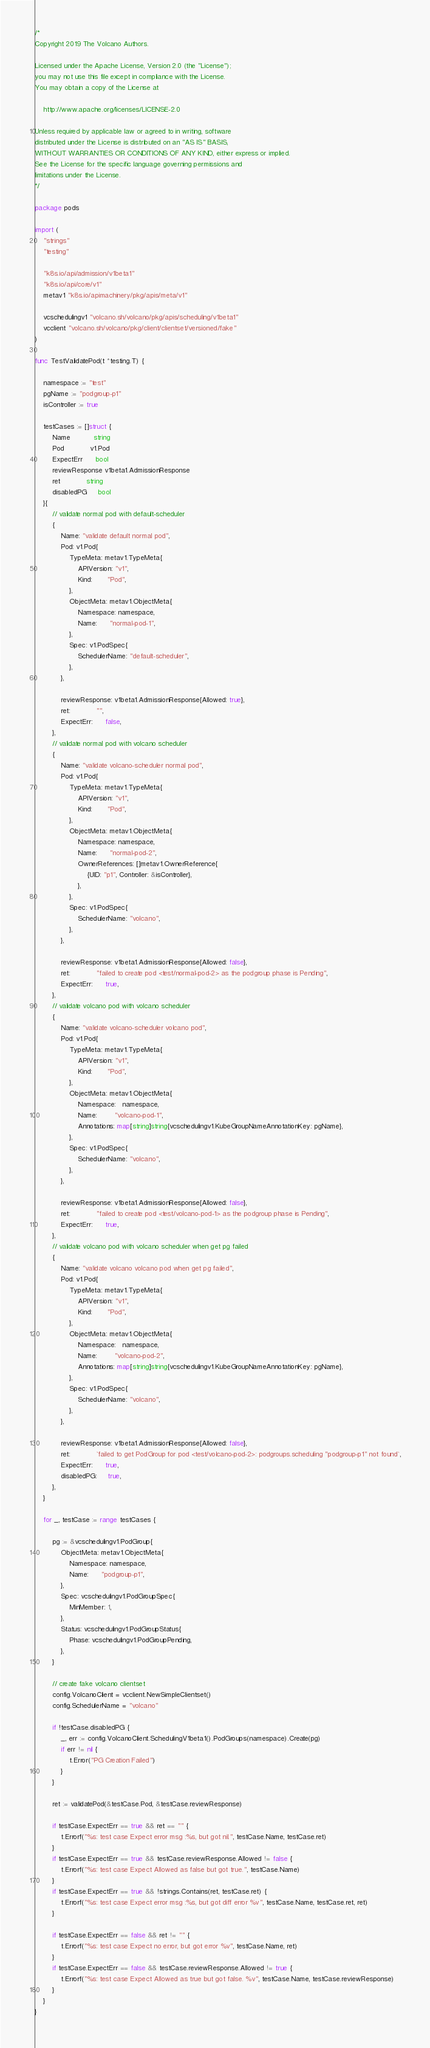Convert code to text. <code><loc_0><loc_0><loc_500><loc_500><_Go_>/*
Copyright 2019 The Volcano Authors.

Licensed under the Apache License, Version 2.0 (the "License");
you may not use this file except in compliance with the License.
You may obtain a copy of the License at

    http://www.apache.org/licenses/LICENSE-2.0

Unless required by applicable law or agreed to in writing, software
distributed under the License is distributed on an "AS IS" BASIS,
WITHOUT WARRANTIES OR CONDITIONS OF ANY KIND, either express or implied.
See the License for the specific language governing permissions and
limitations under the License.
*/

package pods

import (
	"strings"
	"testing"

	"k8s.io/api/admission/v1beta1"
	"k8s.io/api/core/v1"
	metav1 "k8s.io/apimachinery/pkg/apis/meta/v1"

	vcschedulingv1 "volcano.sh/volcano/pkg/apis/scheduling/v1beta1"
	vcclient "volcano.sh/volcano/pkg/client/clientset/versioned/fake"
)

func TestValidatePod(t *testing.T) {

	namespace := "test"
	pgName := "podgroup-p1"
	isController := true

	testCases := []struct {
		Name           string
		Pod            v1.Pod
		ExpectErr      bool
		reviewResponse v1beta1.AdmissionResponse
		ret            string
		disabledPG     bool
	}{
		// validate normal pod with default-scheduler
		{
			Name: "validate default normal pod",
			Pod: v1.Pod{
				TypeMeta: metav1.TypeMeta{
					APIVersion: "v1",
					Kind:       "Pod",
				},
				ObjectMeta: metav1.ObjectMeta{
					Namespace: namespace,
					Name:      "normal-pod-1",
				},
				Spec: v1.PodSpec{
					SchedulerName: "default-scheduler",
				},
			},

			reviewResponse: v1beta1.AdmissionResponse{Allowed: true},
			ret:            "",
			ExpectErr:      false,
		},
		// validate normal pod with volcano scheduler
		{
			Name: "validate volcano-scheduler normal pod",
			Pod: v1.Pod{
				TypeMeta: metav1.TypeMeta{
					APIVersion: "v1",
					Kind:       "Pod",
				},
				ObjectMeta: metav1.ObjectMeta{
					Namespace: namespace,
					Name:      "normal-pod-2",
					OwnerReferences: []metav1.OwnerReference{
						{UID: "p1", Controller: &isController},
					},
				},
				Spec: v1.PodSpec{
					SchedulerName: "volcano",
				},
			},

			reviewResponse: v1beta1.AdmissionResponse{Allowed: false},
			ret:            "failed to create pod <test/normal-pod-2> as the podgroup phase is Pending",
			ExpectErr:      true,
		},
		// validate volcano pod with volcano scheduler
		{
			Name: "validate volcano-scheduler volcano pod",
			Pod: v1.Pod{
				TypeMeta: metav1.TypeMeta{
					APIVersion: "v1",
					Kind:       "Pod",
				},
				ObjectMeta: metav1.ObjectMeta{
					Namespace:   namespace,
					Name:        "volcano-pod-1",
					Annotations: map[string]string{vcschedulingv1.KubeGroupNameAnnotationKey: pgName},
				},
				Spec: v1.PodSpec{
					SchedulerName: "volcano",
				},
			},

			reviewResponse: v1beta1.AdmissionResponse{Allowed: false},
			ret:            "failed to create pod <test/volcano-pod-1> as the podgroup phase is Pending",
			ExpectErr:      true,
		},
		// validate volcano pod with volcano scheduler when get pg failed
		{
			Name: "validate volcano volcano pod when get pg failed",
			Pod: v1.Pod{
				TypeMeta: metav1.TypeMeta{
					APIVersion: "v1",
					Kind:       "Pod",
				},
				ObjectMeta: metav1.ObjectMeta{
					Namespace:   namespace,
					Name:        "volcano-pod-2",
					Annotations: map[string]string{vcschedulingv1.KubeGroupNameAnnotationKey: pgName},
				},
				Spec: v1.PodSpec{
					SchedulerName: "volcano",
				},
			},

			reviewResponse: v1beta1.AdmissionResponse{Allowed: false},
			ret:            `failed to get PodGroup for pod <test/volcano-pod-2>: podgroups.scheduling "podgroup-p1" not found`,
			ExpectErr:      true,
			disabledPG:     true,
		},
	}

	for _, testCase := range testCases {

		pg := &vcschedulingv1.PodGroup{
			ObjectMeta: metav1.ObjectMeta{
				Namespace: namespace,
				Name:      "podgroup-p1",
			},
			Spec: vcschedulingv1.PodGroupSpec{
				MinMember: 1,
			},
			Status: vcschedulingv1.PodGroupStatus{
				Phase: vcschedulingv1.PodGroupPending,
			},
		}

		// create fake volcano clientset
		config.VolcanoClient = vcclient.NewSimpleClientset()
		config.SchedulerName = "volcano"

		if !testCase.disabledPG {
			_, err := config.VolcanoClient.SchedulingV1beta1().PodGroups(namespace).Create(pg)
			if err != nil {
				t.Error("PG Creation Failed")
			}
		}

		ret := validatePod(&testCase.Pod, &testCase.reviewResponse)

		if testCase.ExpectErr == true && ret == "" {
			t.Errorf("%s: test case Expect error msg :%s, but got nil.", testCase.Name, testCase.ret)
		}
		if testCase.ExpectErr == true && testCase.reviewResponse.Allowed != false {
			t.Errorf("%s: test case Expect Allowed as false but got true.", testCase.Name)
		}
		if testCase.ExpectErr == true && !strings.Contains(ret, testCase.ret) {
			t.Errorf("%s: test case Expect error msg :%s, but got diff error %v", testCase.Name, testCase.ret, ret)
		}

		if testCase.ExpectErr == false && ret != "" {
			t.Errorf("%s: test case Expect no error, but got error %v", testCase.Name, ret)
		}
		if testCase.ExpectErr == false && testCase.reviewResponse.Allowed != true {
			t.Errorf("%s: test case Expect Allowed as true but got false. %v", testCase.Name, testCase.reviewResponse)
		}
	}
}
</code> 